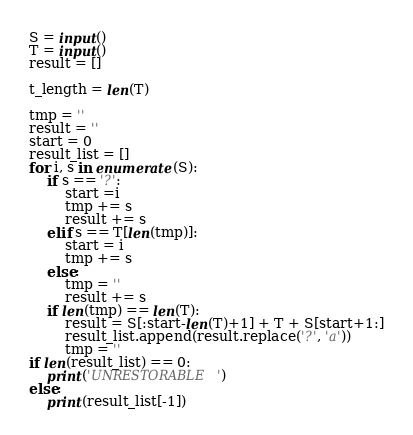<code> <loc_0><loc_0><loc_500><loc_500><_Python_>S = input()
T = input()
result = []

t_length = len(T)

tmp = ''
result = ''
start = 0
result_list = []
for i, s in enumerate(S):
    if s == '?':
        start =i
        tmp += s
        result += s
    elif s == T[len(tmp)]:
        start = i
        tmp += s
    else:
        tmp = ''
        result += s
    if len(tmp) == len(T):
        result = S[:start-len(T)+1] + T + S[start+1:]
        result_list.append(result.replace('?', 'a'))
        tmp = ''
if len(result_list) == 0:
    print('UNRESTORABLE')
else:
    print(result_list[-1])</code> 